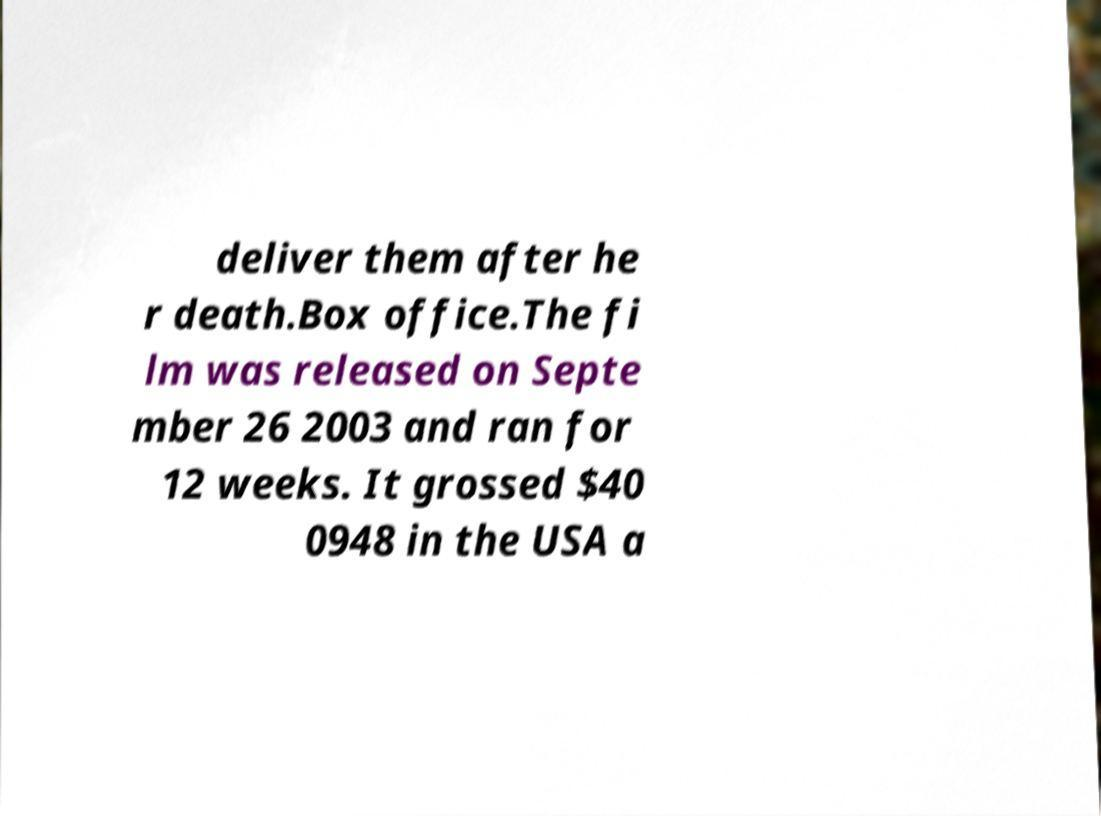I need the written content from this picture converted into text. Can you do that? deliver them after he r death.Box office.The fi lm was released on Septe mber 26 2003 and ran for 12 weeks. It grossed $40 0948 in the USA a 